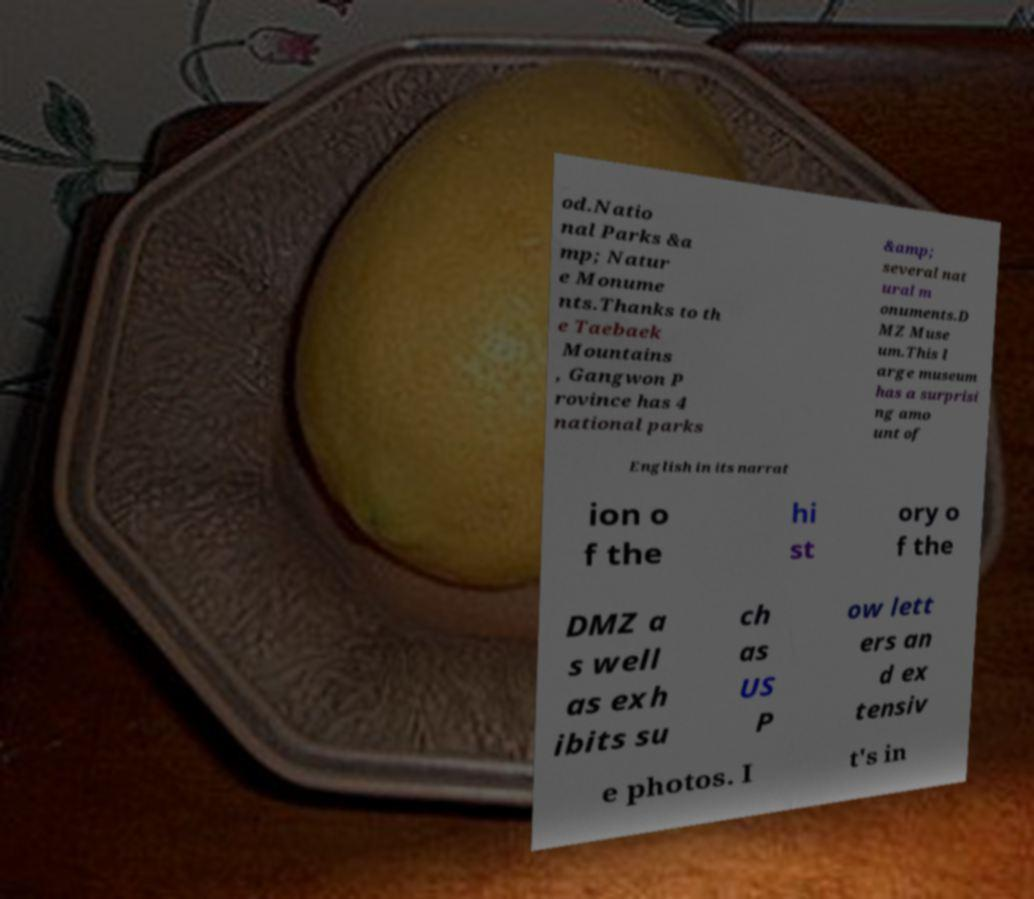For documentation purposes, I need the text within this image transcribed. Could you provide that? od.Natio nal Parks &a mp; Natur e Monume nts.Thanks to th e Taebaek Mountains , Gangwon P rovince has 4 national parks &amp; several nat ural m onuments.D MZ Muse um.This l arge museum has a surprisi ng amo unt of English in its narrat ion o f the hi st ory o f the DMZ a s well as exh ibits su ch as US P ow lett ers an d ex tensiv e photos. I t's in 